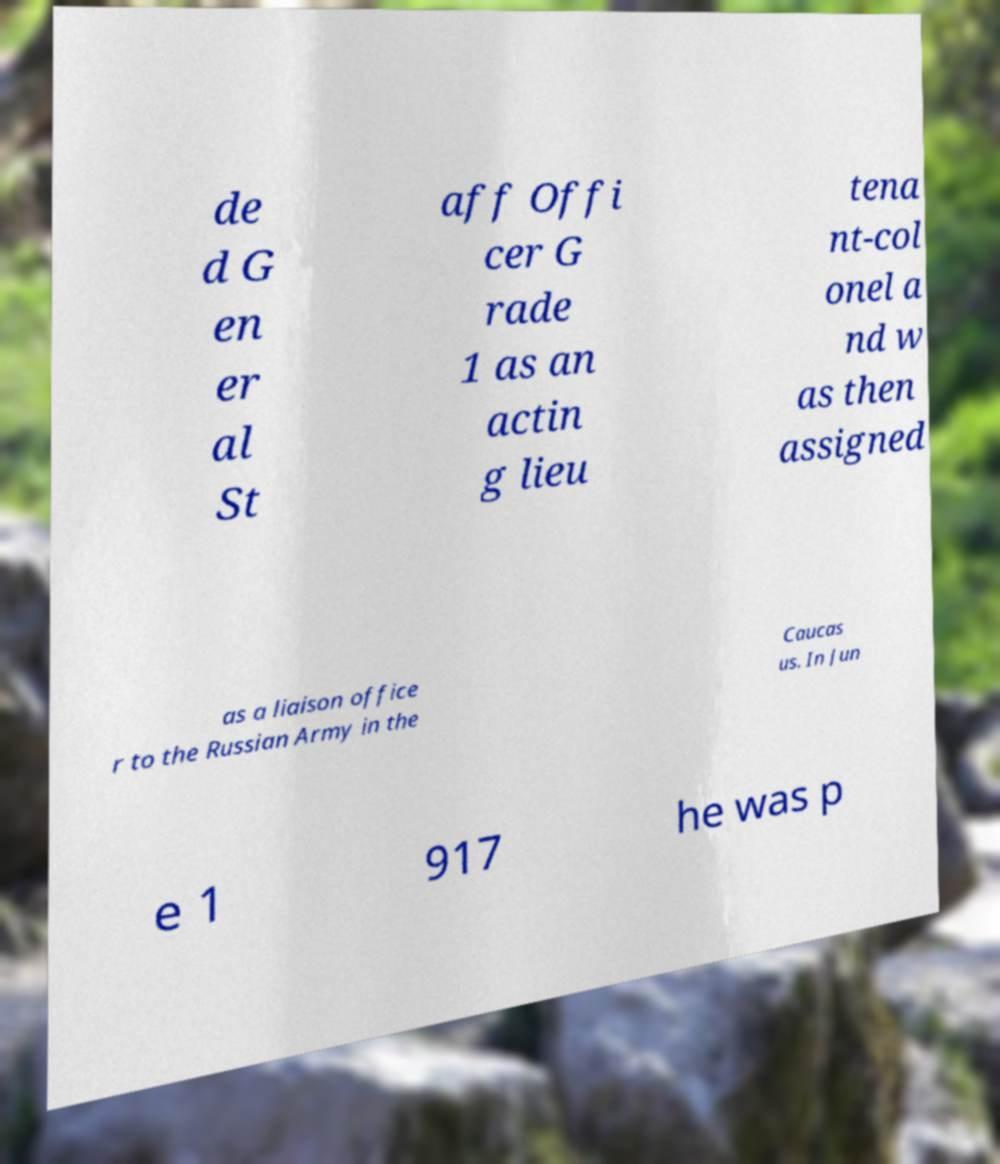Could you assist in decoding the text presented in this image and type it out clearly? de d G en er al St aff Offi cer G rade 1 as an actin g lieu tena nt-col onel a nd w as then assigned as a liaison office r to the Russian Army in the Caucas us. In Jun e 1 917 he was p 